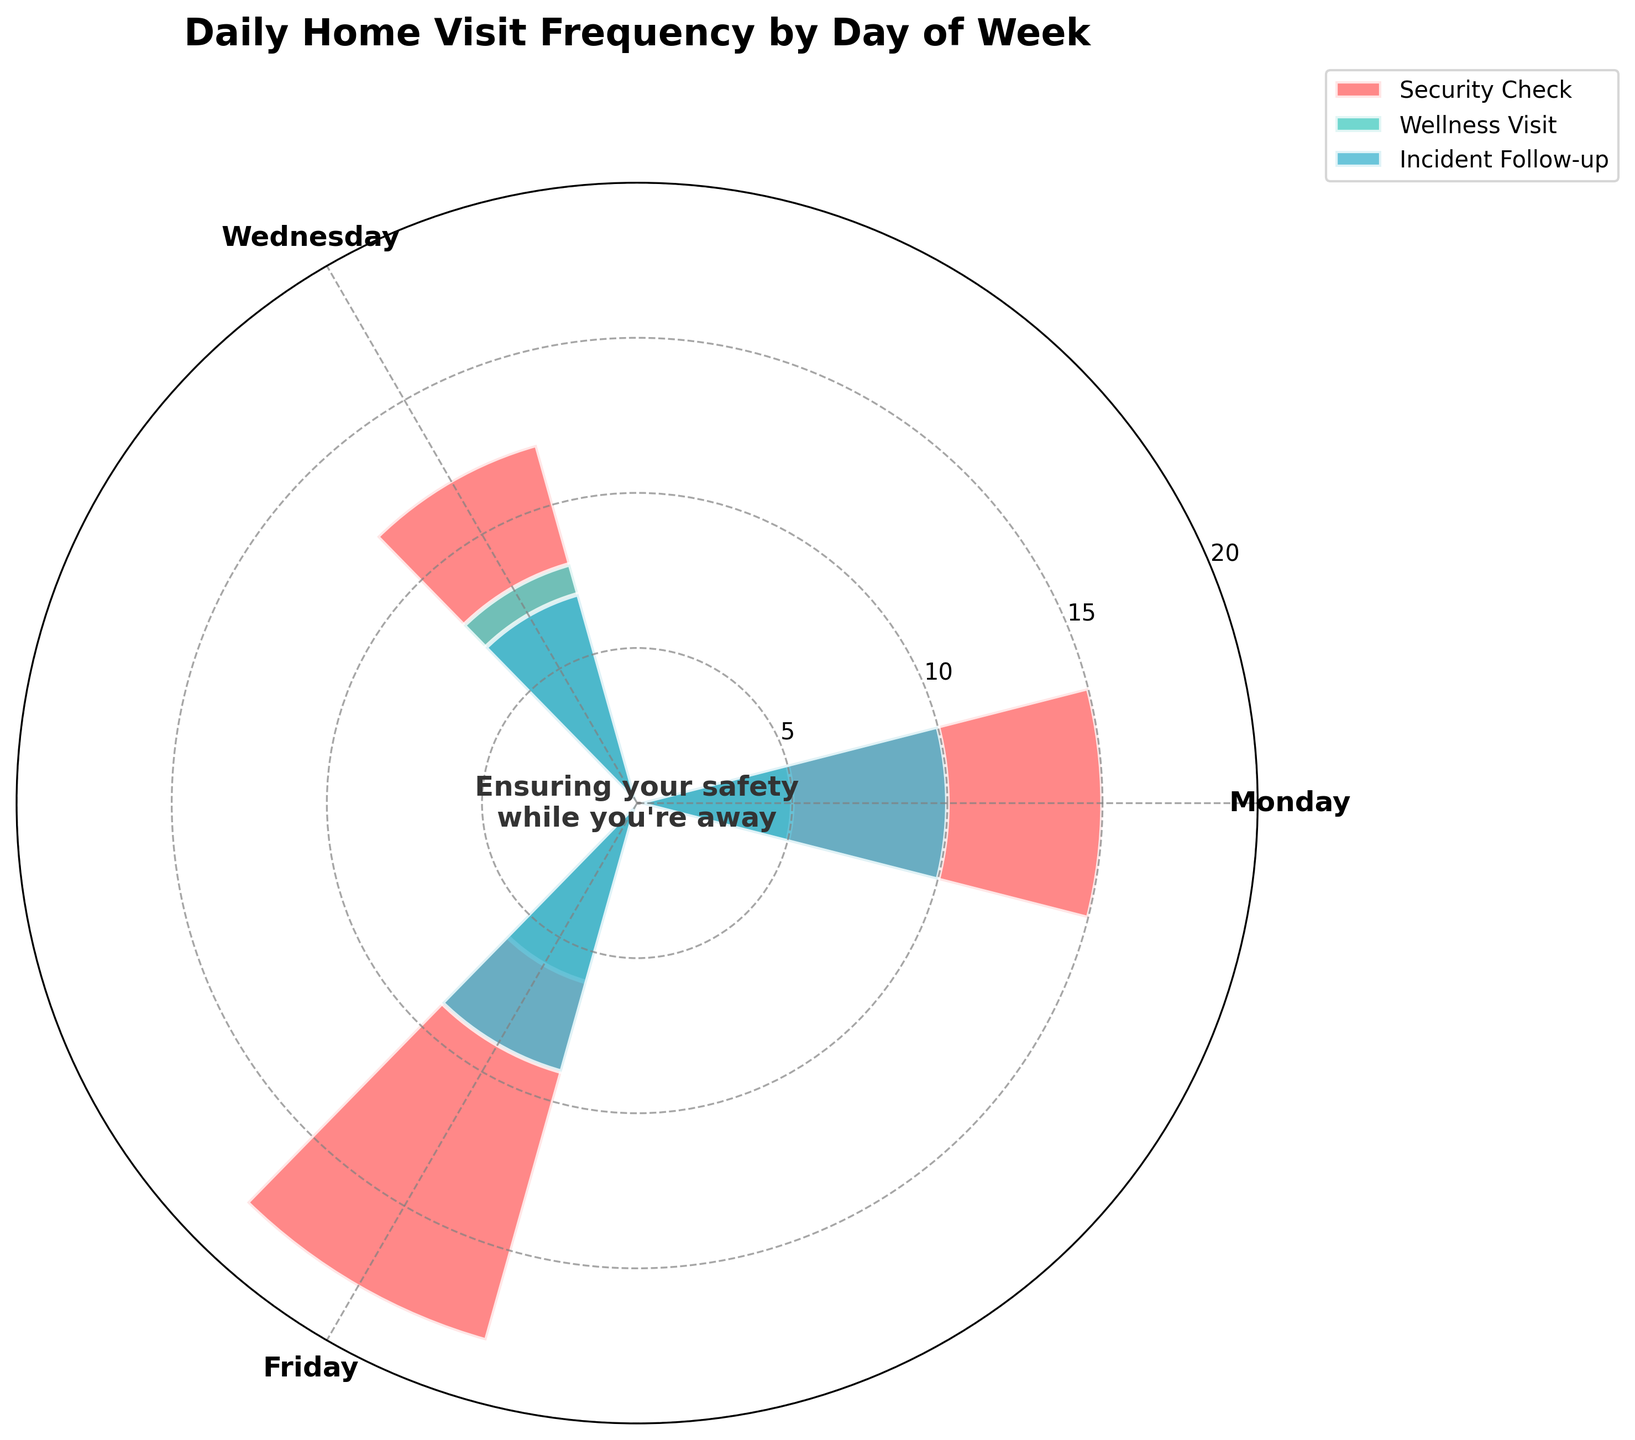What is the title of the figure? The title can be seen at the top of the chart. It reads "Daily Home Visit Frequency by Day of Week."
Answer: Daily Home Visit Frequency by Day of Week What color represents Security Check visits? By looking at the colors in the legend, Security Check visits are represented by the first color, which is a shade of red.
Answer: Red What is the total number of visits on Monday? Sum the frequencies of all visit types on Monday: (15 Security Check) + (5 Wellness Visit) + (10 Incident Follow-up) = 30 visits
Answer: 30 What is the average number of Wellness Visits per day? Sum the frequencies of Wellness Visits for all days and divide by the number of days: (5 Monday) + (8 Wednesday) + (6 Friday) = 19; 19 / 3 = ~6.33
Answer: ~6.33 Which day has the highest number of Security Check visits? Compare the frequencies of Security Check visits on each day: Monday (15), Wednesday (12), and Friday (18). The highest frequency is on Friday.
Answer: Friday Is the number of Incident Follow-up visits greater on Friday than on Wednesday? Compare the Incident Follow-up visits on Friday (9) with those on Wednesday (7). Since 9 is greater than 7, the answer is yes.
Answer: Yes On which day is the frequency of Wellness Visits the lowest? Compare the frequencies of Wellness Visits for each day: Monday (5), Wednesday (8), and Friday (6). The lowest frequency is on Monday.
Answer: Monday What type of visit has the least frequency on Wednesday? Compare the frequencies of all visit types on Wednesday: Security Check (12), Wellness Visit (8), Incident Follow-up (7). Incident Follow-up has the least frequency.
Answer: Incident Follow-up 